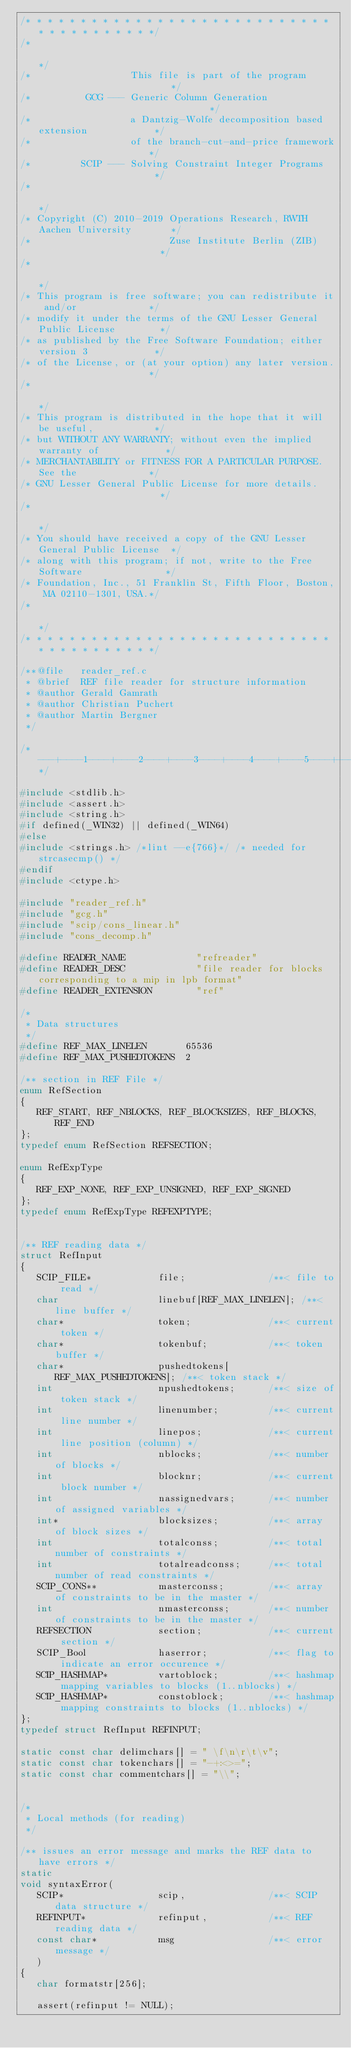Convert code to text. <code><loc_0><loc_0><loc_500><loc_500><_C_>/* * * * * * * * * * * * * * * * * * * * * * * * * * * * * * * * * * * * * * */
/*                                                                           */
/*                  This file is part of the program                         */
/*          GCG --- Generic Column Generation                                */
/*                  a Dantzig-Wolfe decomposition based extension            */
/*                  of the branch-cut-and-price framework                    */
/*         SCIP --- Solving Constraint Integer Programs                      */
/*                                                                           */
/* Copyright (C) 2010-2019 Operations Research, RWTH Aachen University       */
/*                         Zuse Institute Berlin (ZIB)                       */
/*                                                                           */
/* This program is free software; you can redistribute it and/or             */
/* modify it under the terms of the GNU Lesser General Public License        */
/* as published by the Free Software Foundation; either version 3            */
/* of the License, or (at your option) any later version.                    */
/*                                                                           */
/* This program is distributed in the hope that it will be useful,           */
/* but WITHOUT ANY WARRANTY; without even the implied warranty of            */
/* MERCHANTABILITY or FITNESS FOR A PARTICULAR PURPOSE.  See the             */
/* GNU Lesser General Public License for more details.                       */
/*                                                                           */
/* You should have received a copy of the GNU Lesser General Public License  */
/* along with this program; if not, write to the Free Software               */
/* Foundation, Inc., 51 Franklin St, Fifth Floor, Boston, MA 02110-1301, USA.*/
/*                                                                           */
/* * * * * * * * * * * * * * * * * * * * * * * * * * * * * * * * * * * * * * */

/**@file   reader_ref.c
 * @brief  REF file reader for structure information
 * @author Gerald Gamrath
 * @author Christian Puchert
 * @author Martin Bergner
 */

/*---+----1----+----2----+----3----+----4----+----5----+----6----+----7----+----8----+----9----+----0----+----1----+----2*/

#include <stdlib.h>
#include <assert.h>
#include <string.h>
#if defined(_WIN32) || defined(_WIN64)
#else
#include <strings.h> /*lint --e{766}*/ /* needed for strcasecmp() */
#endif
#include <ctype.h>

#include "reader_ref.h"
#include "gcg.h"
#include "scip/cons_linear.h"
#include "cons_decomp.h"

#define READER_NAME             "refreader"
#define READER_DESC             "file reader for blocks corresponding to a mip in lpb format"
#define READER_EXTENSION        "ref"

/*
 * Data structures
 */
#define REF_MAX_LINELEN       65536
#define REF_MAX_PUSHEDTOKENS  2

/** section in REF File */
enum RefSection
{
   REF_START, REF_NBLOCKS, REF_BLOCKSIZES, REF_BLOCKS, REF_END
};
typedef enum RefSection REFSECTION;

enum RefExpType
{
   REF_EXP_NONE, REF_EXP_UNSIGNED, REF_EXP_SIGNED
};
typedef enum RefExpType REFEXPTYPE;


/** REF reading data */
struct RefInput
{
   SCIP_FILE*            file;               /**< file to read */
   char                  linebuf[REF_MAX_LINELEN]; /**< line buffer */
   char*                 token;              /**< current token */
   char*                 tokenbuf;           /**< token buffer */
   char*                 pushedtokens[REF_MAX_PUSHEDTOKENS]; /**< token stack */
   int                   npushedtokens;      /**< size of token stack */
   int                   linenumber;         /**< current line number */
   int                   linepos;            /**< current line position (column) */
   int                   nblocks;            /**< number of blocks */
   int                   blocknr;            /**< current block number */
   int                   nassignedvars;      /**< number of assigned variables */
   int*                  blocksizes;         /**< array of block sizes */
   int                   totalconss;         /**< total number of constraints */
   int                   totalreadconss;     /**< total number of read constraints */
   SCIP_CONS**           masterconss;        /**< array of constraints to be in the master */
   int                   nmasterconss;       /**< number of constraints to be in the master */
   REFSECTION            section;            /**< current section */
   SCIP_Bool             haserror;           /**< flag to indicate an error occurence */
   SCIP_HASHMAP*         vartoblock;         /**< hashmap mapping variables to blocks (1..nblocks) */
   SCIP_HASHMAP*         constoblock;        /**< hashmap mapping constraints to blocks (1..nblocks) */
};
typedef struct RefInput REFINPUT;

static const char delimchars[] = " \f\n\r\t\v";
static const char tokenchars[] = "-+:<>=";
static const char commentchars[] = "\\";


/*
 * Local methods (for reading)
 */

/** issues an error message and marks the REF data to have errors */
static
void syntaxError(
   SCIP*                 scip,               /**< SCIP data structure */
   REFINPUT*             refinput,           /**< REF reading data */
   const char*           msg                 /**< error message */
   )
{
   char formatstr[256];

   assert(refinput != NULL);
</code> 